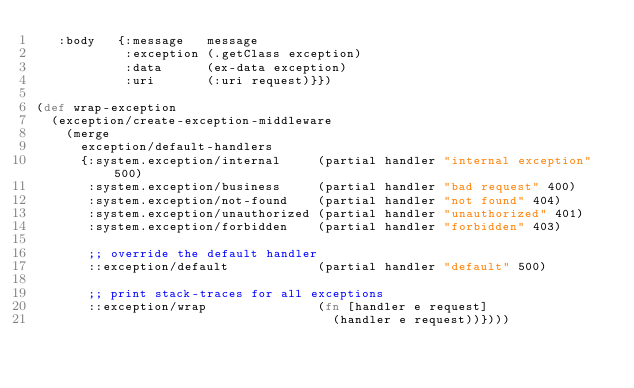<code> <loc_0><loc_0><loc_500><loc_500><_Clojure_>   :body   {:message   message
            :exception (.getClass exception)
            :data      (ex-data exception)
            :uri       (:uri request)}})

(def wrap-exception
  (exception/create-exception-middleware
    (merge
      exception/default-handlers
      {:system.exception/internal     (partial handler "internal exception" 500)
       :system.exception/business     (partial handler "bad request" 400)
       :system.exception/not-found    (partial handler "not found" 404)
       :system.exception/unauthorized (partial handler "unauthorized" 401)
       :system.exception/forbidden    (partial handler "forbidden" 403)

       ;; override the default handler
       ::exception/default            (partial handler "default" 500)

       ;; print stack-traces for all exceptions
       ::exception/wrap               (fn [handler e request]
                                        (handler e request))})))
</code> 